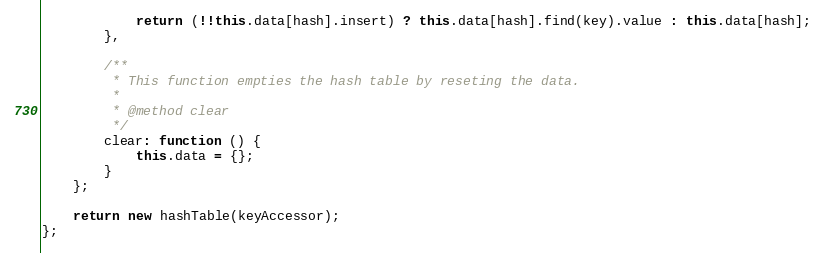<code> <loc_0><loc_0><loc_500><loc_500><_JavaScript_>
            return (!!this.data[hash].insert) ? this.data[hash].find(key).value : this.data[hash];
        },

        /**
         * This function empties the hash table by reseting the data.
         *
         * @method clear
         */
        clear: function () {
            this.data = {};
        }
    };

    return new hashTable(keyAccessor);
};
</code> 